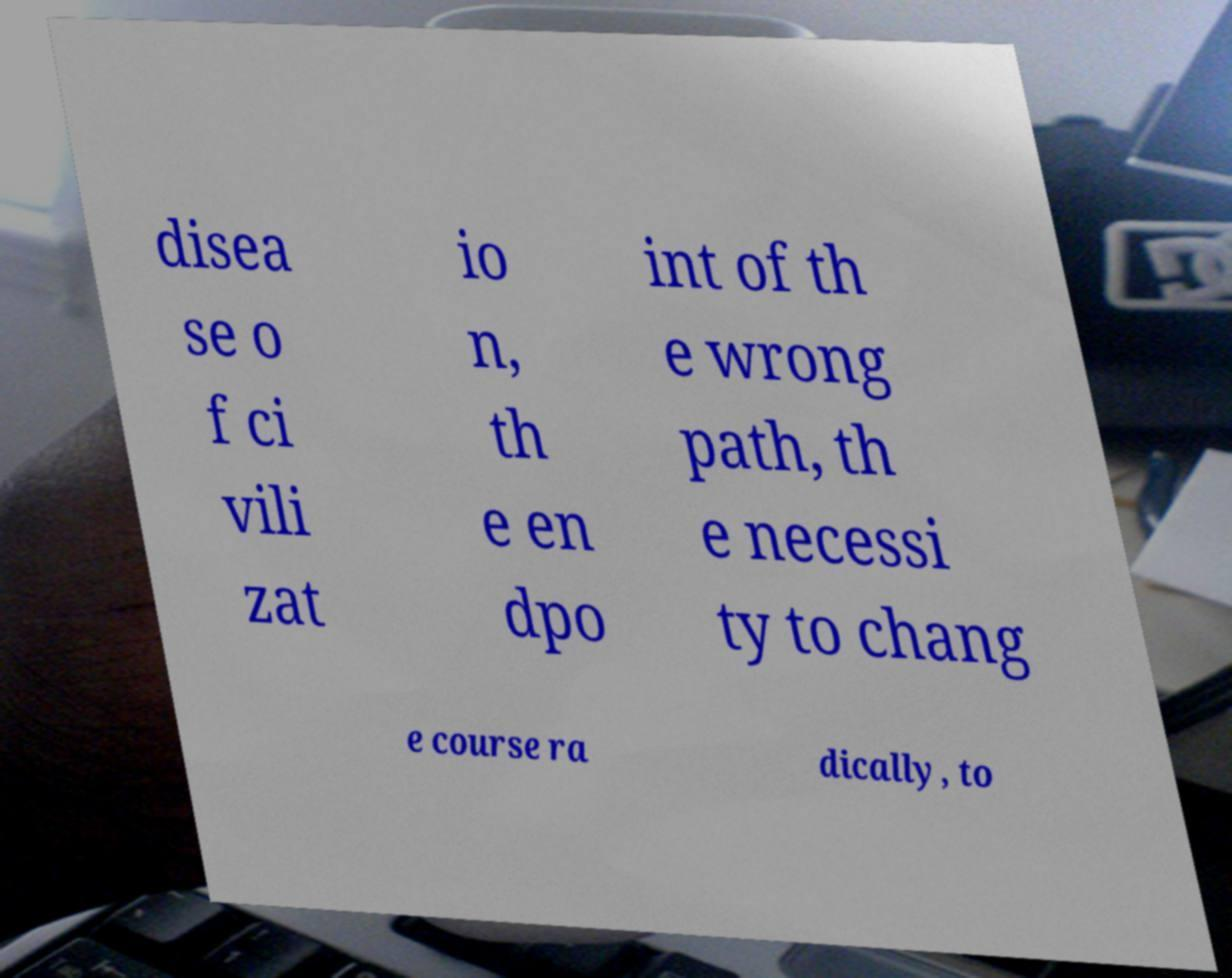Can you read and provide the text displayed in the image?This photo seems to have some interesting text. Can you extract and type it out for me? disea se o f ci vili zat io n, th e en dpo int of th e wrong path, th e necessi ty to chang e course ra dically, to 